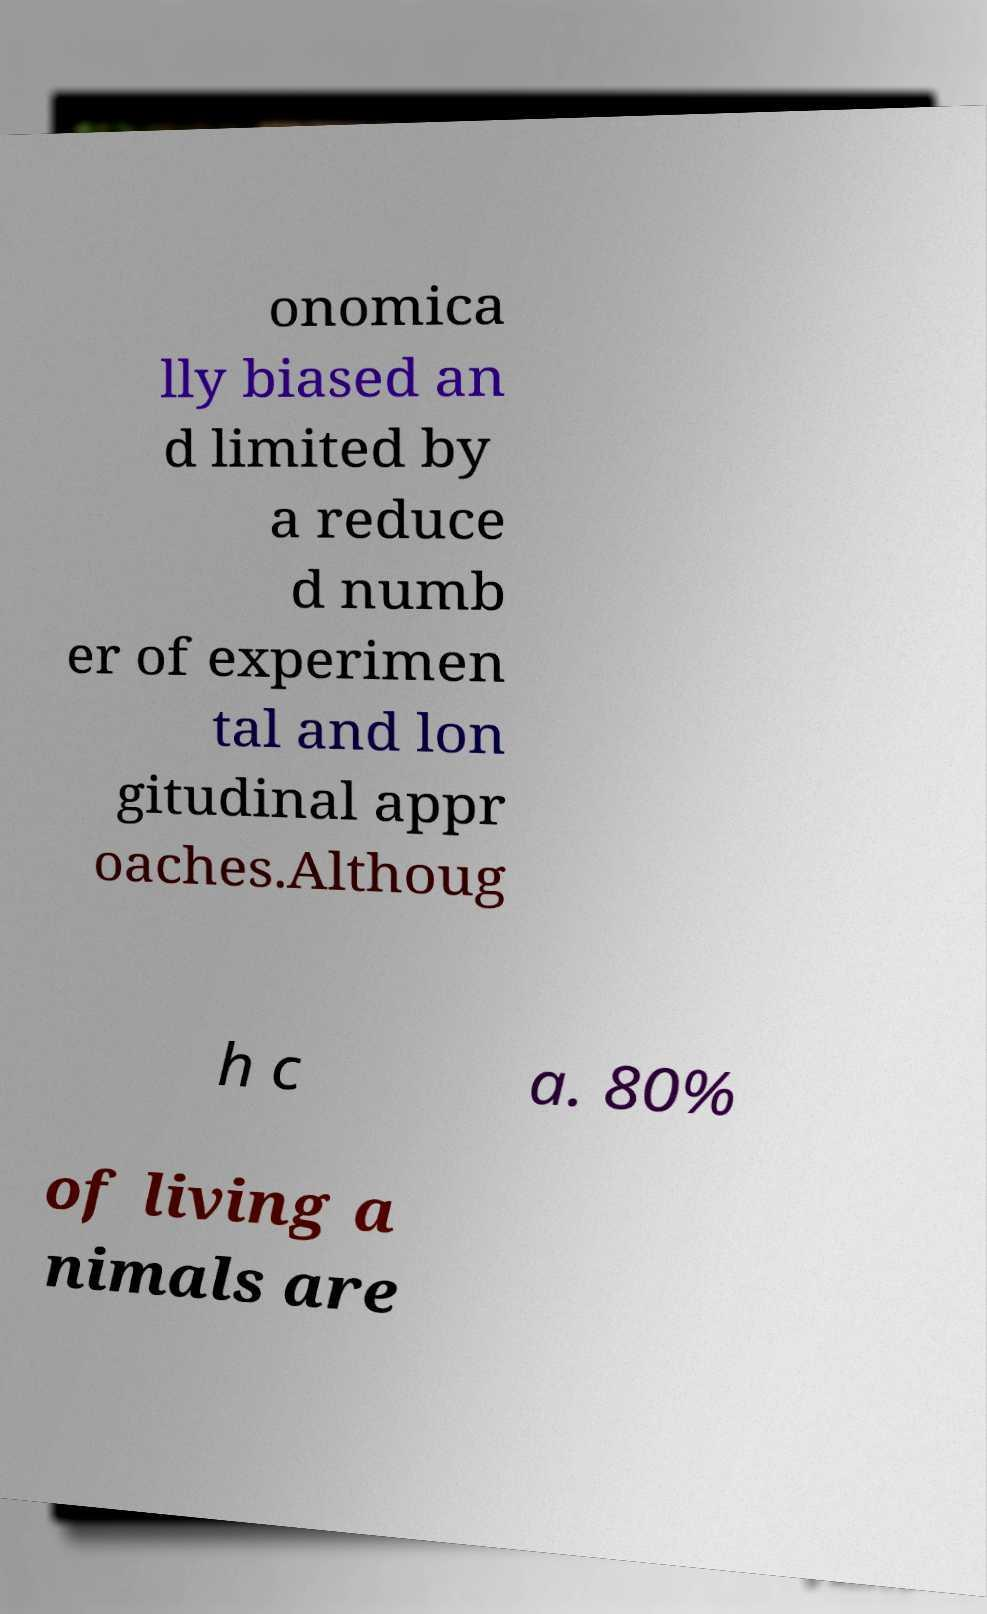Can you accurately transcribe the text from the provided image for me? onomica lly biased an d limited by a reduce d numb er of experimen tal and lon gitudinal appr oaches.Althoug h c a. 80% of living a nimals are 